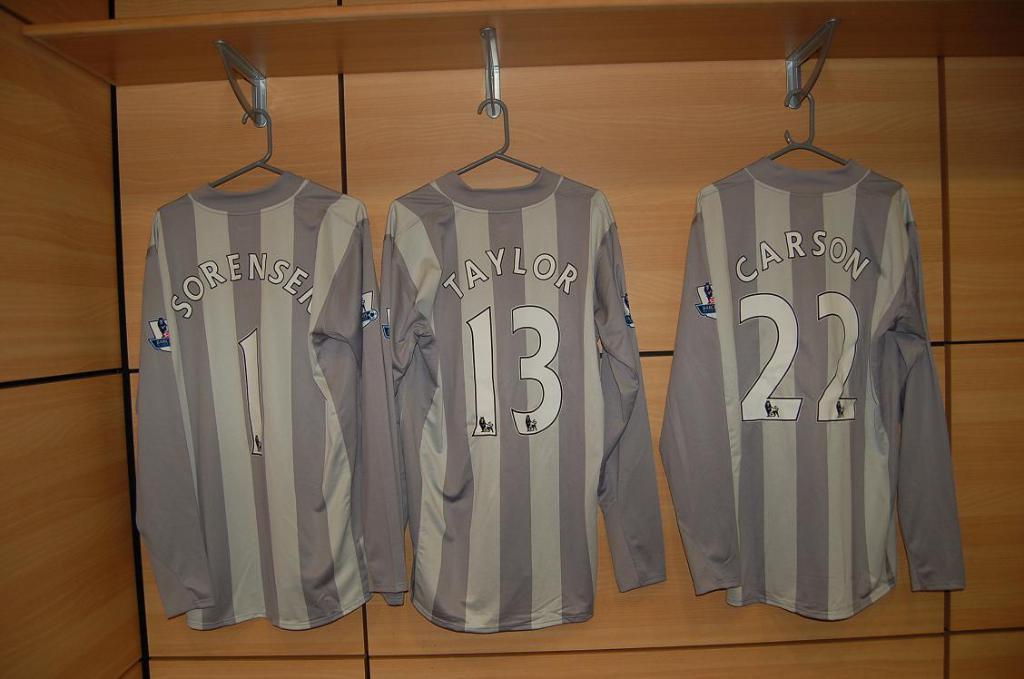What name is on the middle shirt?
Offer a very short reply. Taylor. 